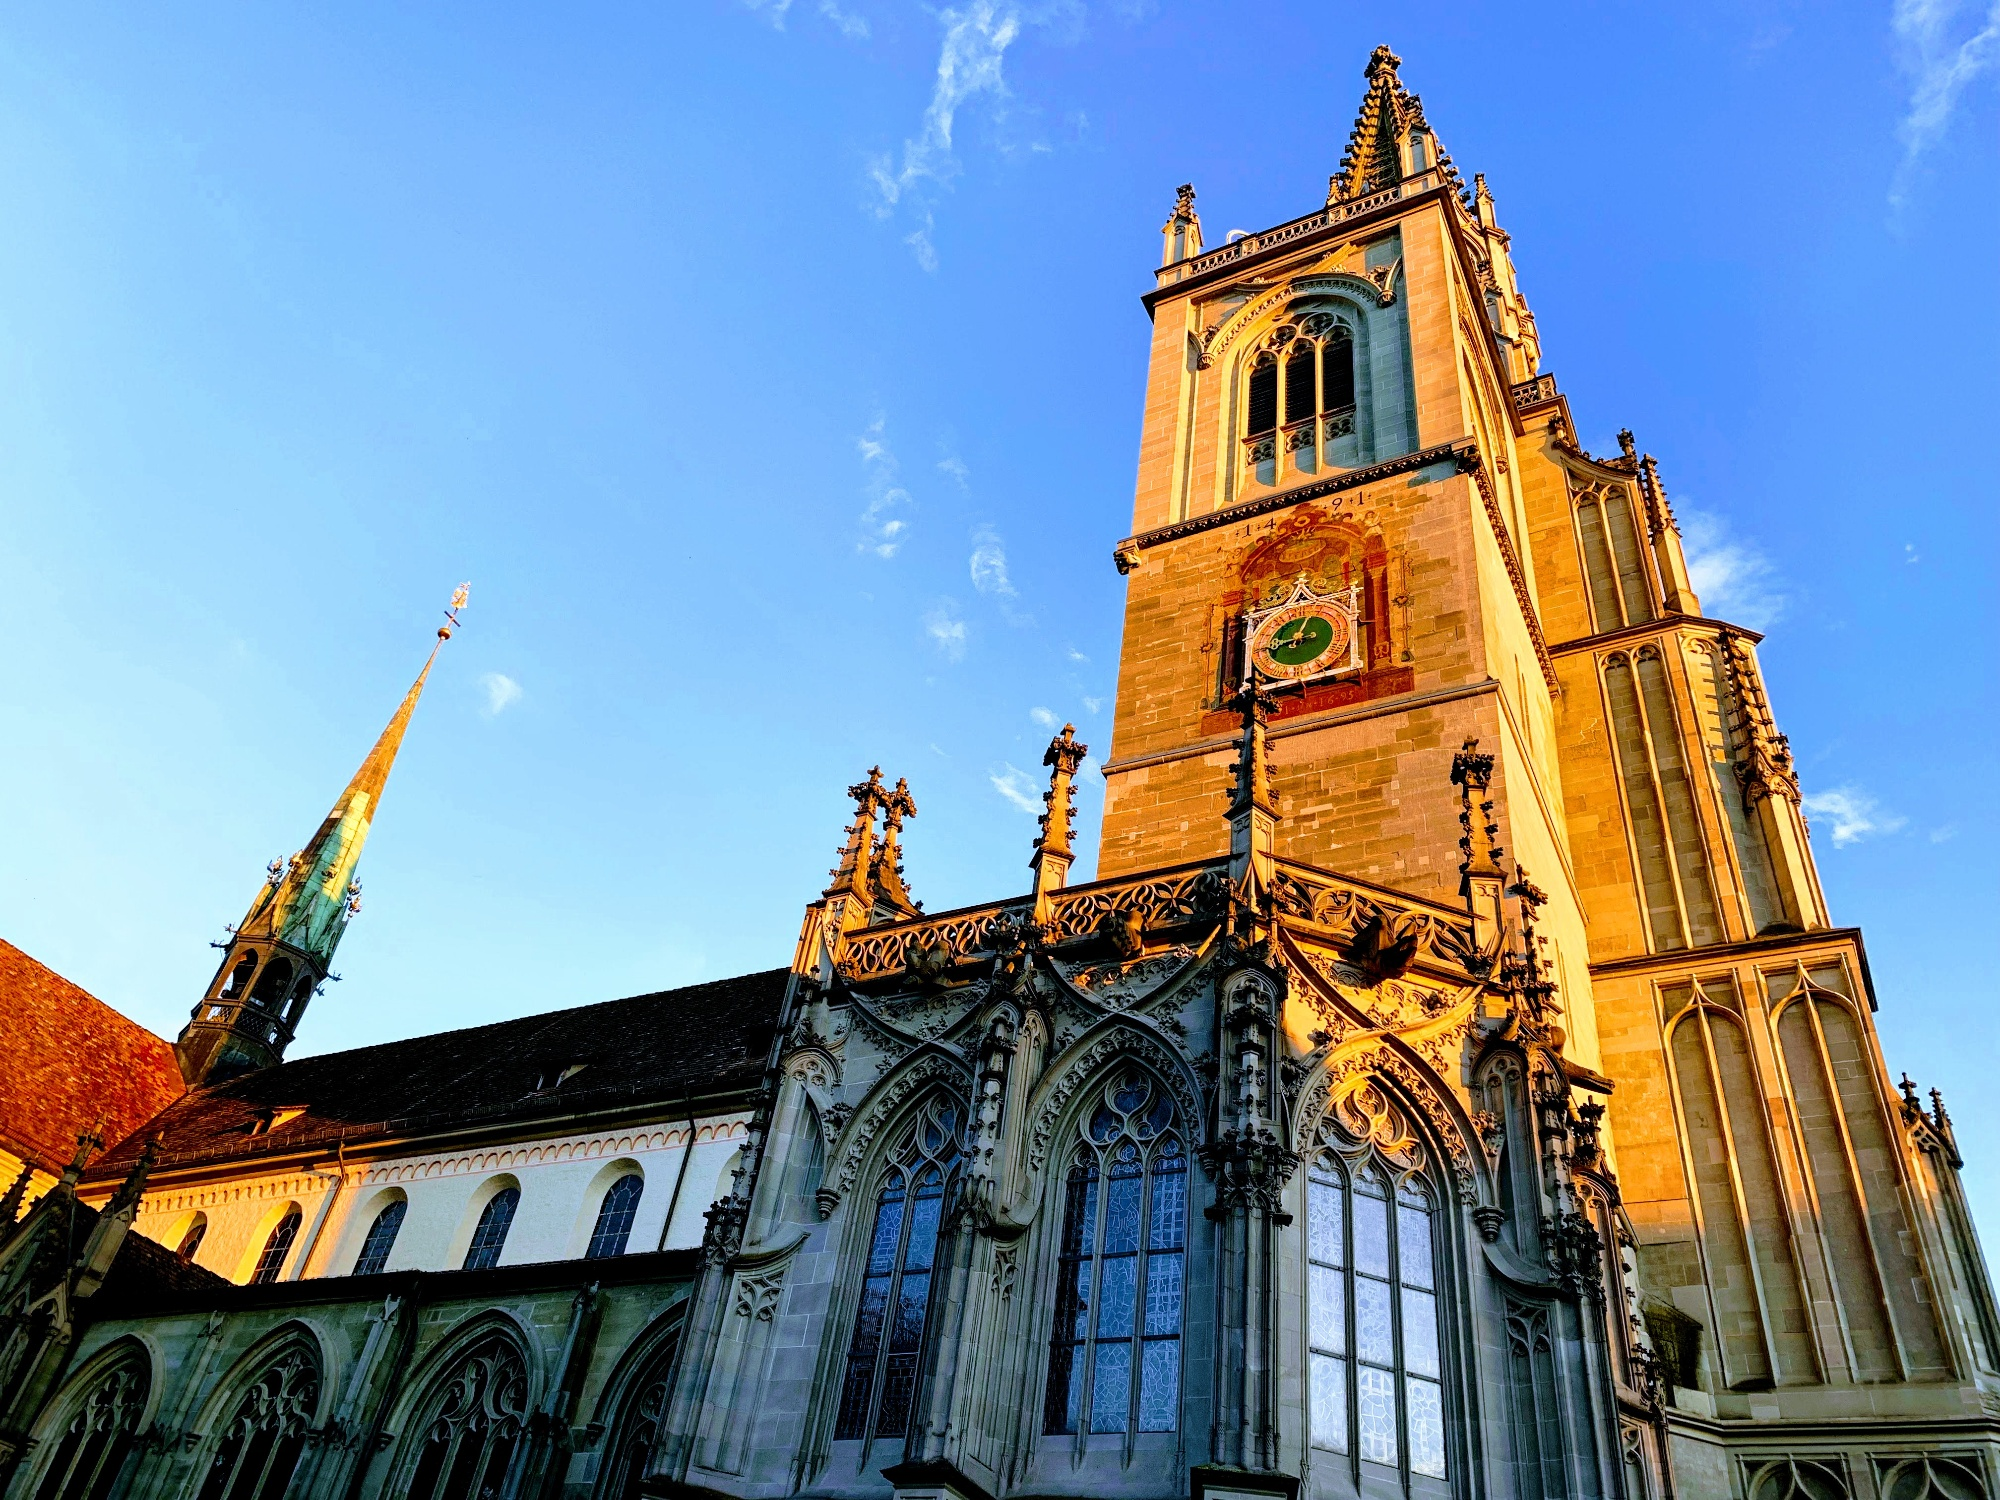What unique architectural elements can be found on the facade of the cathedral? The facade of Konstanz Minster features several unique architectural elements that showcase its Gothic heritage. One of the most striking features is the array of intricate stone carvings depicting biblical scenes and figures, designed to inspire and instruct the faithful. The cathedral's tall, pointed arches and ribbed vaults add both height and elegance to the structure. Gargoyles and grotesques adorn the exterior, serving both as decorative elements and functional rain spouts. The large, pointed windows are filled with colorful stained glass depicting religious iconography, casting a mesmerizing light into the interior. The flying buttresses not only provide structural support but also contribute to the cathedral's majestic silhouette. The central tower with its ornate clock face and delicate spire serves as both a visual focal point and a testament to the craftsmanship of its builders. 